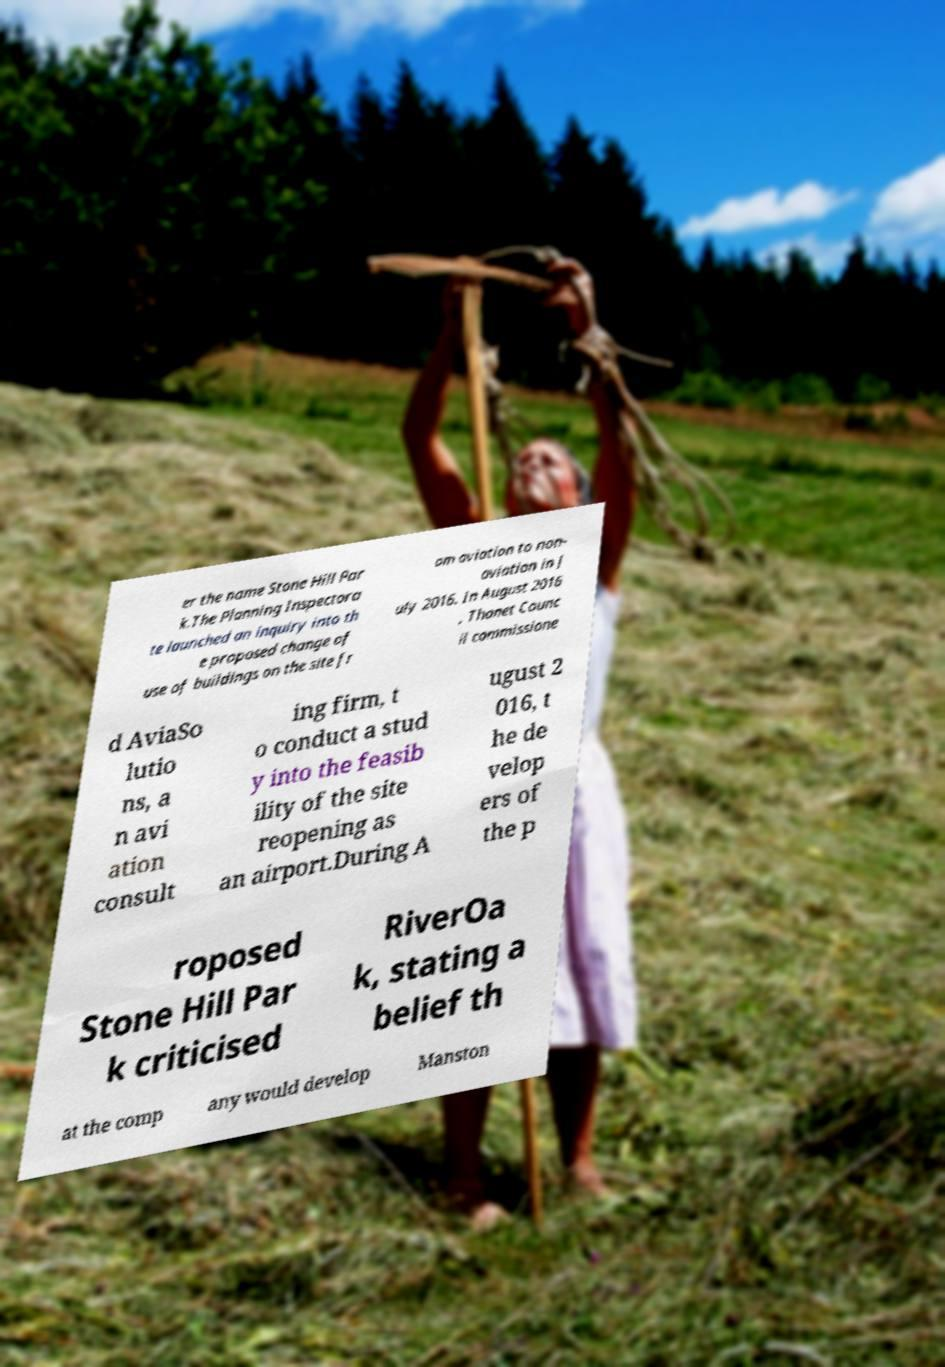I need the written content from this picture converted into text. Can you do that? er the name Stone Hill Par k.The Planning Inspectora te launched an inquiry into th e proposed change of use of buildings on the site fr om aviation to non- aviation in J uly 2016. In August 2016 , Thanet Counc il commissione d AviaSo lutio ns, a n avi ation consult ing firm, t o conduct a stud y into the feasib ility of the site reopening as an airport.During A ugust 2 016, t he de velop ers of the p roposed Stone Hill Par k criticised RiverOa k, stating a belief th at the comp any would develop Manston 